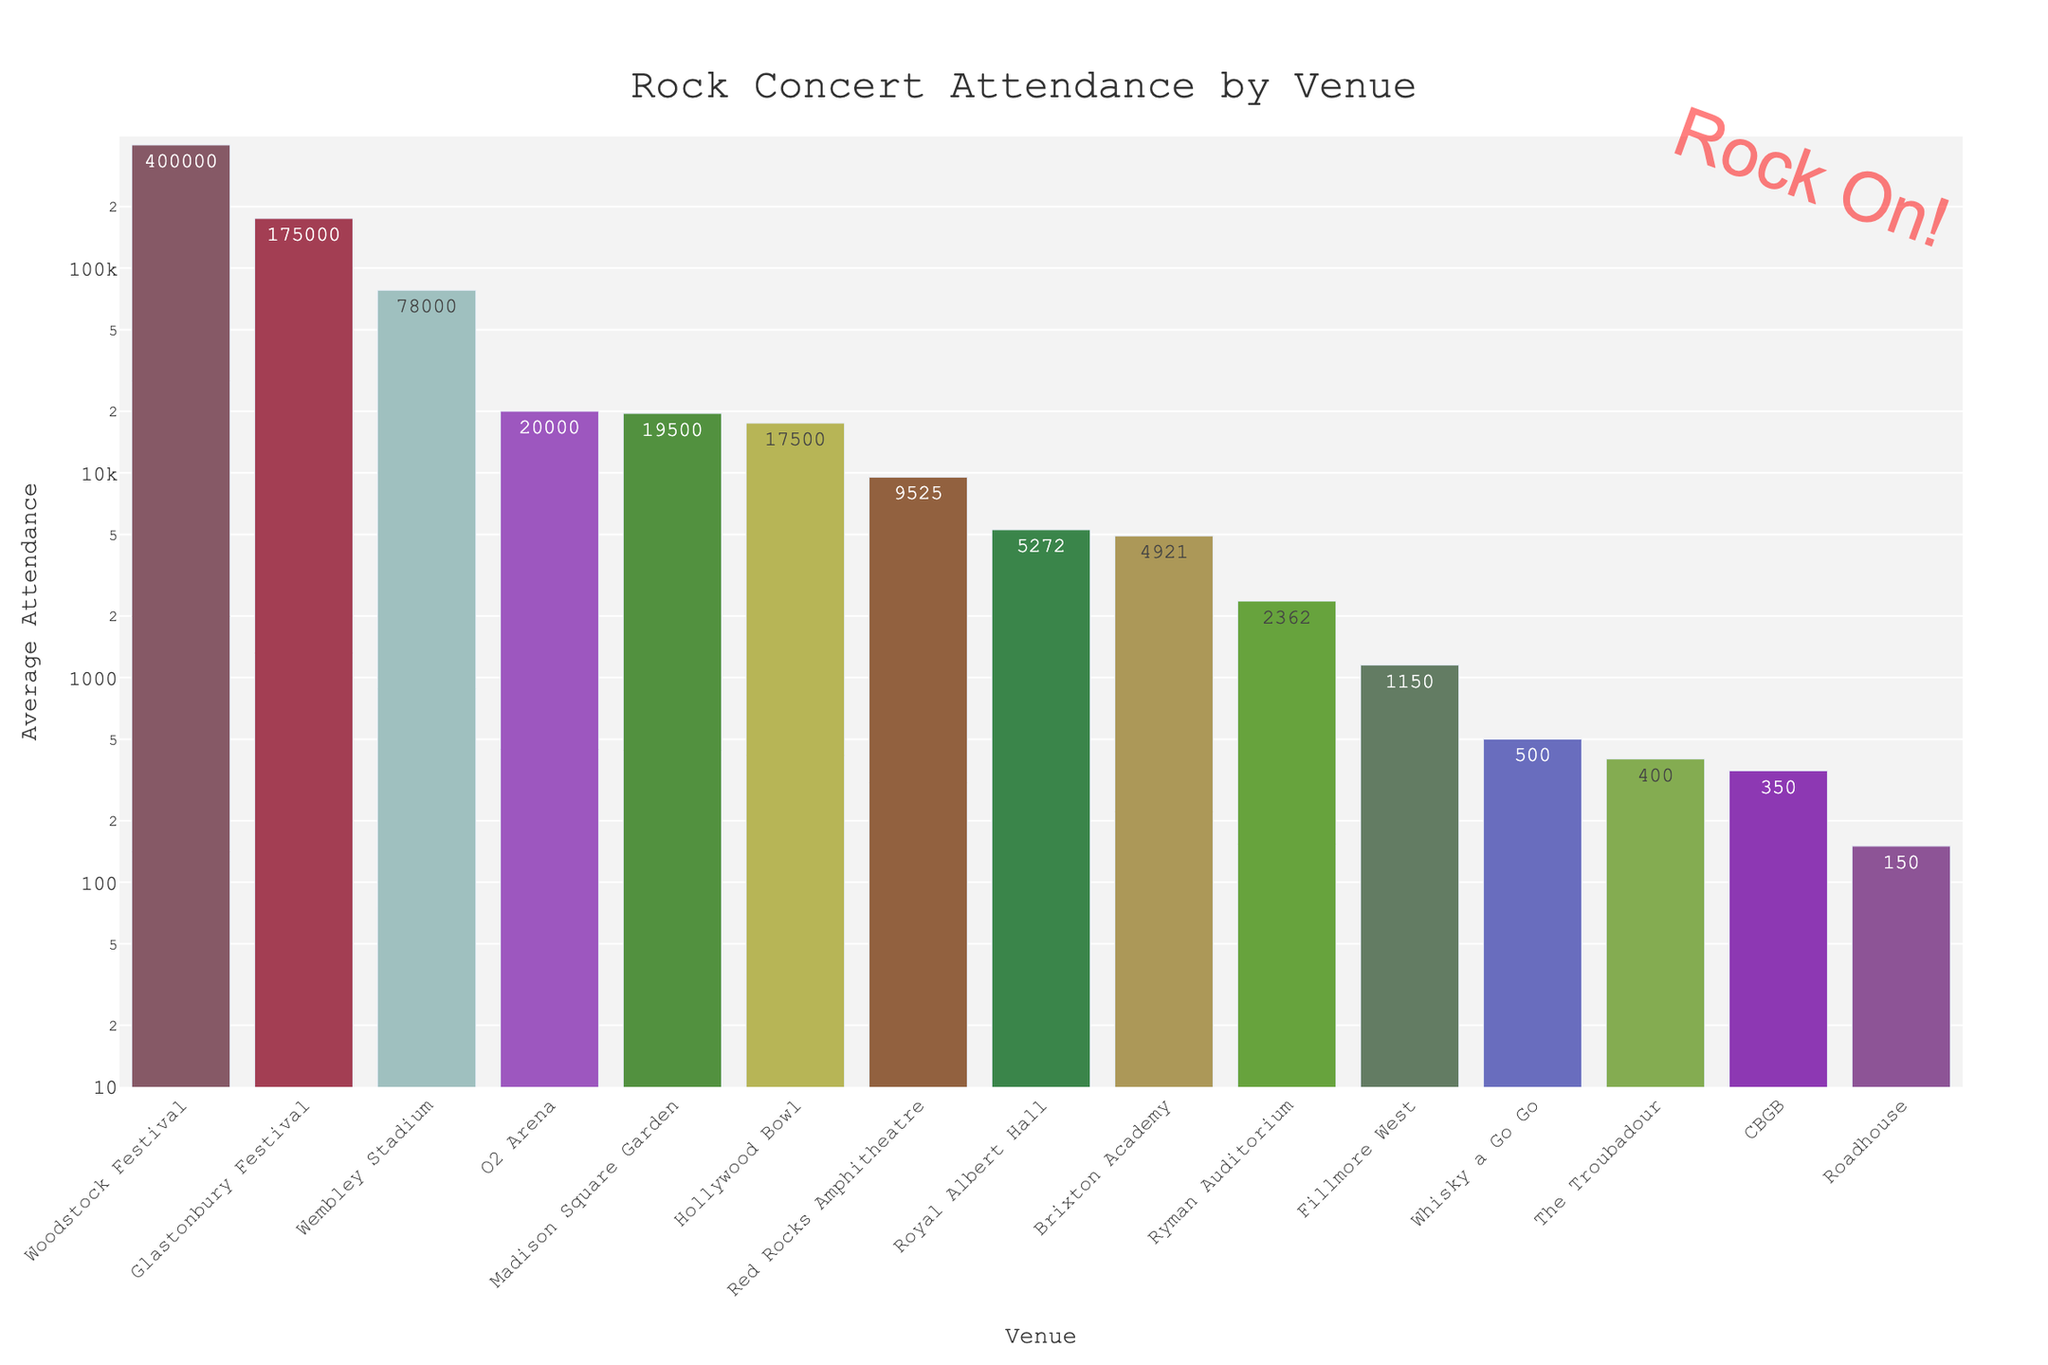What is the venue with the highest average attendance? By looking at the highest bar in the chart, you can identify the venue with the highest average attendance. The bar for Woodstock Festival is significantly taller than the others.
Answer: Woodstock Festival Which venue has the lowest average attendance? The smallest bar represents the venue with the lowest average attendance. The Roadhouse appears to have the smallest height.
Answer: Roadhouse How does the average attendance at Glastonbury Festival compare to Madison Square Garden? Find the bars for Glastonbury Festival and Madison Square Garden and compare their heights. Glastonbury Festival is much higher than Madison Square Garden.
Answer: Glastonbury Festival is higher Which two venues have the most similar average attendance? By visually comparing the bar heights, find the two venues whose bars are closest in height. Madison Square Garden and Hollywood Bowl have bars of similar heights.
Answer: Madison Square Garden and Hollywood Bowl Is there more than an order of magnitude difference in average attendance between the smallest and largest venues? Compare bars for the smallest and largest values. The smallest is Roadhouse at 150, and the largest is Woodstock Festival at 400,000. An order of magnitude is a factor of 10, so check if 400,000 is more than 10 times 150.
Answer: Yes Which venue has a slightly higher average attendance, Fillmore West or Ryman Auditorium? Compare the heights of the bars for Fillmore West and Ryman Auditorium. Ryman Auditorium is slightly higher.
Answer: Ryman Auditorium How does the attendance at Wembley Stadium compare to Madison Square Garden? Look at the bars for Wembley Stadium and Madison Square Garden. Wembley Stadium is much higher than Madison Square Garden.
Answer: Wembley Stadium is higher 